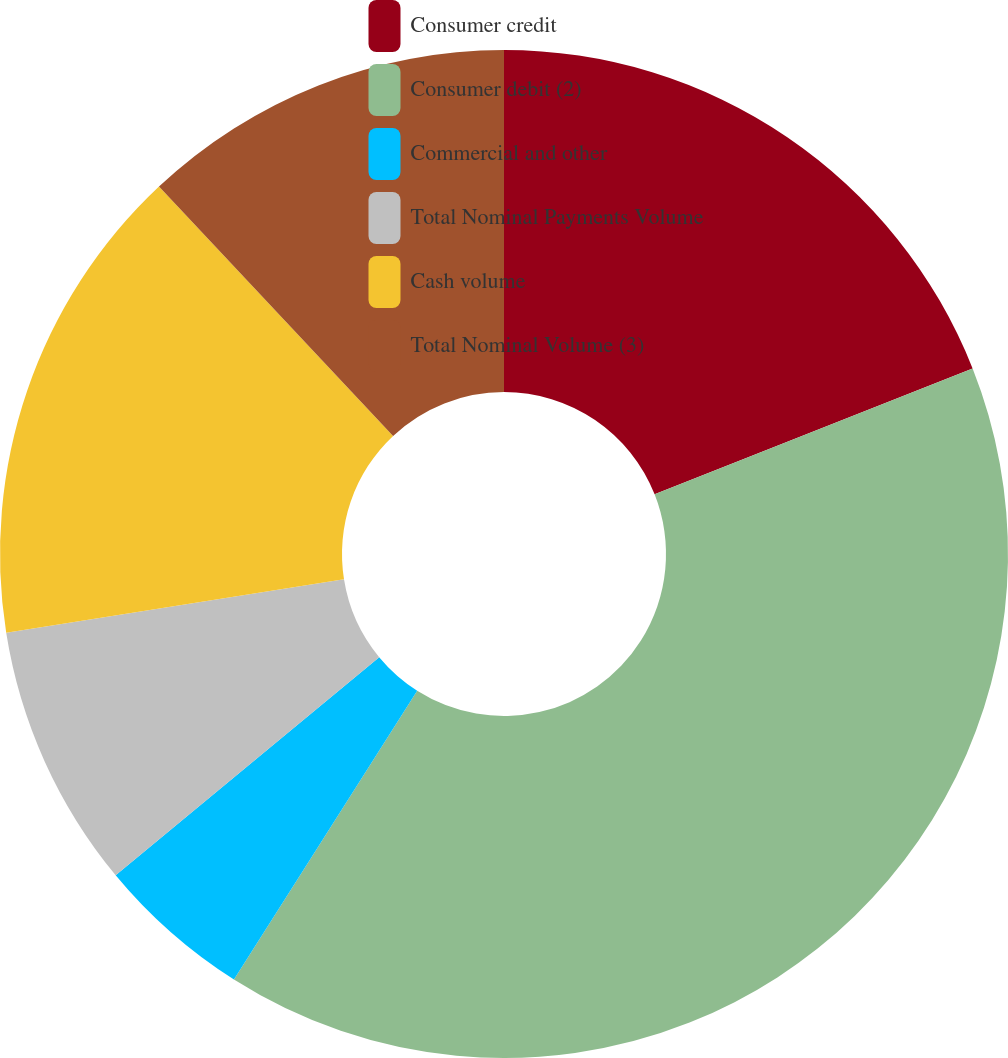Convert chart. <chart><loc_0><loc_0><loc_500><loc_500><pie_chart><fcel>Consumer credit<fcel>Consumer debit (2)<fcel>Commercial and other<fcel>Total Nominal Payments Volume<fcel>Cash volume<fcel>Total Nominal Volume (3)<nl><fcel>19.0%<fcel>40.0%<fcel>5.0%<fcel>8.5%<fcel>15.5%<fcel>12.0%<nl></chart> 